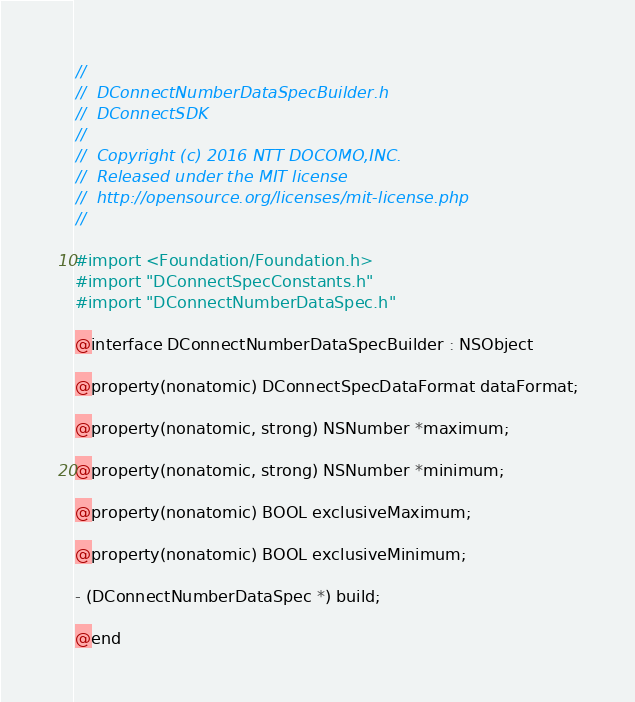Convert code to text. <code><loc_0><loc_0><loc_500><loc_500><_C_>//
//  DConnectNumberDataSpecBuilder.h
//  DConnectSDK
//
//  Copyright (c) 2016 NTT DOCOMO,INC.
//  Released under the MIT license
//  http://opensource.org/licenses/mit-license.php
//

#import <Foundation/Foundation.h>
#import "DConnectSpecConstants.h"
#import "DConnectNumberDataSpec.h"

@interface DConnectNumberDataSpecBuilder : NSObject

@property(nonatomic) DConnectSpecDataFormat dataFormat;

@property(nonatomic, strong) NSNumber *maximum;

@property(nonatomic, strong) NSNumber *minimum;

@property(nonatomic) BOOL exclusiveMaximum;

@property(nonatomic) BOOL exclusiveMinimum;

- (DConnectNumberDataSpec *) build;

@end
</code> 